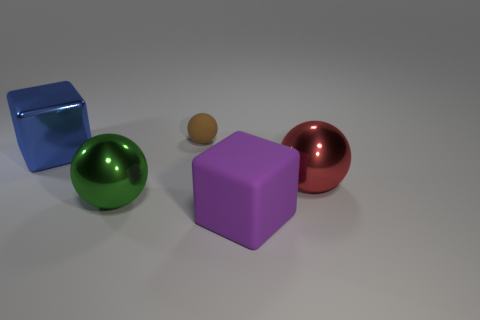Add 4 large cyan metal cylinders. How many objects exist? 9 Subtract all big shiny balls. How many balls are left? 1 Subtract all purple blocks. How many blocks are left? 1 Subtract all balls. How many objects are left? 2 Subtract all blue spheres. Subtract all large blue metal cubes. How many objects are left? 4 Add 3 small brown spheres. How many small brown spheres are left? 4 Add 5 large yellow shiny cubes. How many large yellow shiny cubes exist? 5 Subtract 0 blue cylinders. How many objects are left? 5 Subtract all gray balls. Subtract all red blocks. How many balls are left? 3 